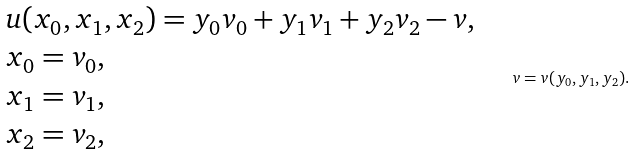<formula> <loc_0><loc_0><loc_500><loc_500>\begin{array} { l } u ( x _ { 0 } , x _ { 1 } , x _ { 2 } ) = y _ { 0 } v _ { 0 } + y _ { 1 } v _ { 1 } + y _ { 2 } v _ { 2 } - v , \\ x _ { 0 } = v _ { 0 } , \\ x _ { 1 } = v _ { 1 } , \\ x _ { 2 } = v _ { 2 } , \\ \end{array} \quad v = v ( y _ { 0 } , y _ { 1 } , y _ { 2 } ) .</formula> 